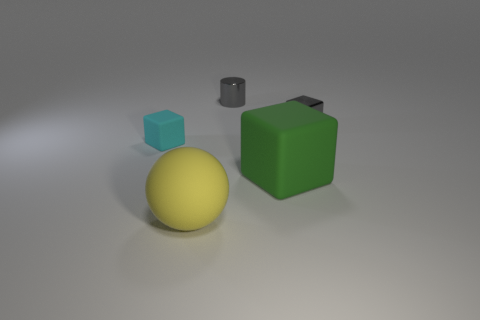Add 3 small blue shiny cylinders. How many objects exist? 8 Subtract all cubes. How many objects are left? 2 Add 4 balls. How many balls exist? 5 Subtract 0 blue cylinders. How many objects are left? 5 Subtract all large green metallic objects. Subtract all small gray cylinders. How many objects are left? 4 Add 1 cylinders. How many cylinders are left? 2 